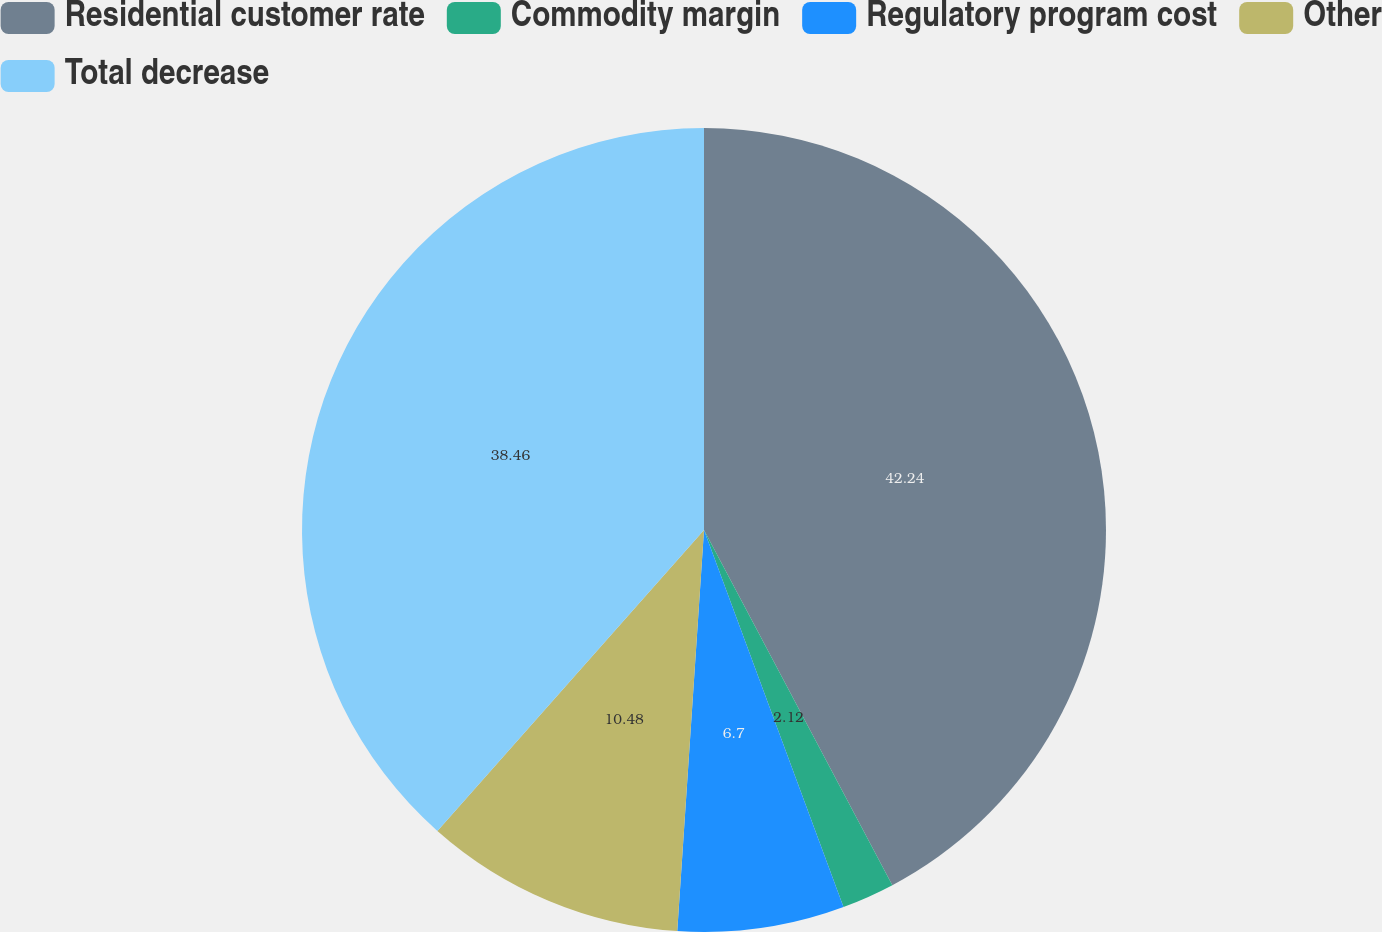<chart> <loc_0><loc_0><loc_500><loc_500><pie_chart><fcel>Residential customer rate<fcel>Commodity margin<fcel>Regulatory program cost<fcel>Other<fcel>Total decrease<nl><fcel>42.24%<fcel>2.12%<fcel>6.7%<fcel>10.48%<fcel>38.46%<nl></chart> 